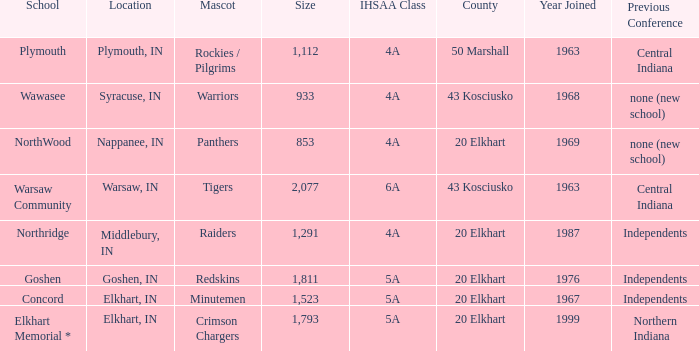Would you be able to parse every entry in this table? {'header': ['School', 'Location', 'Mascot', 'Size', 'IHSAA Class', 'County', 'Year Joined', 'Previous Conference'], 'rows': [['Plymouth', 'Plymouth, IN', 'Rockies / Pilgrims', '1,112', '4A', '50 Marshall', '1963', 'Central Indiana'], ['Wawasee', 'Syracuse, IN', 'Warriors', '933', '4A', '43 Kosciusko', '1968', 'none (new school)'], ['NorthWood', 'Nappanee, IN', 'Panthers', '853', '4A', '20 Elkhart', '1969', 'none (new school)'], ['Warsaw Community', 'Warsaw, IN', 'Tigers', '2,077', '6A', '43 Kosciusko', '1963', 'Central Indiana'], ['Northridge', 'Middlebury, IN', 'Raiders', '1,291', '4A', '20 Elkhart', '1987', 'Independents'], ['Goshen', 'Goshen, IN', 'Redskins', '1,811', '5A', '20 Elkhart', '1976', 'Independents'], ['Concord', 'Elkhart, IN', 'Minutemen', '1,523', '5A', '20 Elkhart', '1967', 'Independents'], ['Elkhart Memorial *', 'Elkhart, IN', 'Crimson Chargers', '1,793', '5A', '20 Elkhart', '1999', 'Northern Indiana']]} What is the IHSAA class for the team located in Middlebury, IN? 4A. 